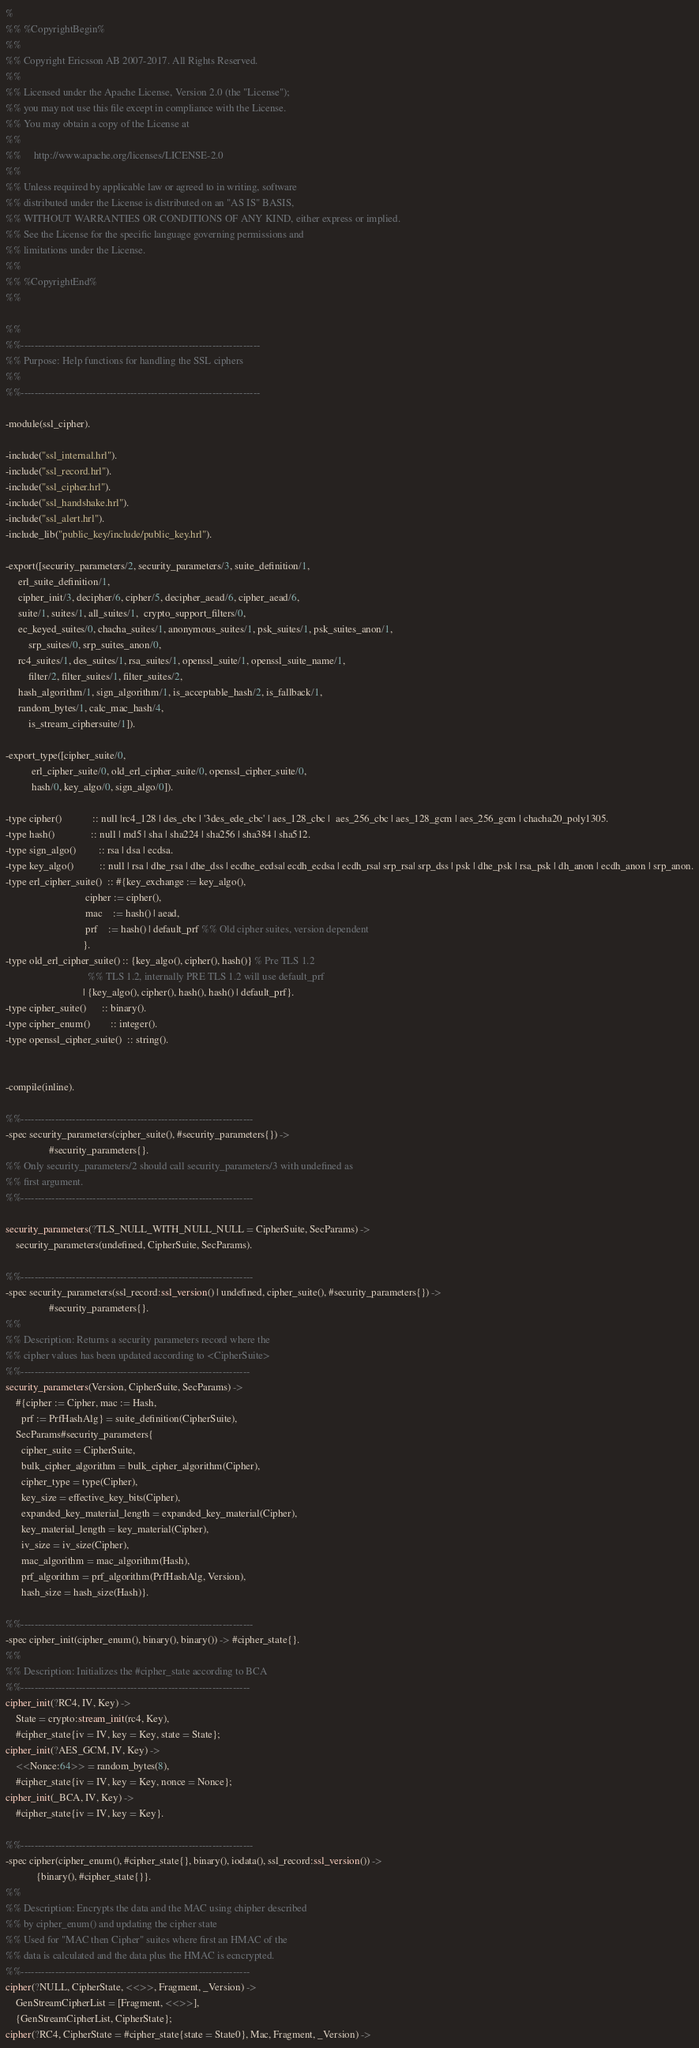<code> <loc_0><loc_0><loc_500><loc_500><_Erlang_>%
%% %CopyrightBegin%
%%
%% Copyright Ericsson AB 2007-2017. All Rights Reserved.
%%
%% Licensed under the Apache License, Version 2.0 (the "License");
%% you may not use this file except in compliance with the License.
%% You may obtain a copy of the License at
%%
%%     http://www.apache.org/licenses/LICENSE-2.0
%%
%% Unless required by applicable law or agreed to in writing, software
%% distributed under the License is distributed on an "AS IS" BASIS,
%% WITHOUT WARRANTIES OR CONDITIONS OF ANY KIND, either express or implied.
%% See the License for the specific language governing permissions and
%% limitations under the License.
%%
%% %CopyrightEnd%
%%

%%
%%----------------------------------------------------------------------
%% Purpose: Help functions for handling the SSL ciphers
%% 
%%----------------------------------------------------------------------

-module(ssl_cipher).

-include("ssl_internal.hrl").
-include("ssl_record.hrl").
-include("ssl_cipher.hrl").
-include("ssl_handshake.hrl").
-include("ssl_alert.hrl").
-include_lib("public_key/include/public_key.hrl").

-export([security_parameters/2, security_parameters/3, suite_definition/1,
	 erl_suite_definition/1,
	 cipher_init/3, decipher/6, cipher/5, decipher_aead/6, cipher_aead/6,
	 suite/1, suites/1, all_suites/1,  crypto_support_filters/0,
	 ec_keyed_suites/0, chacha_suites/1, anonymous_suites/1, psk_suites/1, psk_suites_anon/1, 
         srp_suites/0, srp_suites_anon/0,
	 rc4_suites/1, des_suites/1, rsa_suites/1, openssl_suite/1, openssl_suite_name/1, 
         filter/2, filter_suites/1, filter_suites/2,
	 hash_algorithm/1, sign_algorithm/1, is_acceptable_hash/2, is_fallback/1,
	 random_bytes/1, calc_mac_hash/4,
         is_stream_ciphersuite/1]).

-export_type([cipher_suite/0,
	      erl_cipher_suite/0, old_erl_cipher_suite/0, openssl_cipher_suite/0,
	      hash/0, key_algo/0, sign_algo/0]).

-type cipher()            :: null |rc4_128 | des_cbc | '3des_ede_cbc' | aes_128_cbc |  aes_256_cbc | aes_128_gcm | aes_256_gcm | chacha20_poly1305.
-type hash()              :: null | md5 | sha | sha224 | sha256 | sha384 | sha512.
-type sign_algo()         :: rsa | dsa | ecdsa.
-type key_algo()          :: null | rsa | dhe_rsa | dhe_dss | ecdhe_ecdsa| ecdh_ecdsa | ecdh_rsa| srp_rsa| srp_dss | psk | dhe_psk | rsa_psk | dh_anon | ecdh_anon | srp_anon.
-type erl_cipher_suite()  :: #{key_exchange := key_algo(),
                               cipher := cipher(),
                               mac    := hash() | aead,
                               prf    := hash() | default_prf %% Old cipher suites, version dependent
                              }.  
-type old_erl_cipher_suite() :: {key_algo(), cipher(), hash()} % Pre TLS 1.2 
                                %% TLS 1.2, internally PRE TLS 1.2 will use default_prf
                              | {key_algo(), cipher(), hash(), hash() | default_prf}. 
-type cipher_suite()      :: binary().
-type cipher_enum()        :: integer().
-type openssl_cipher_suite()  :: string().


-compile(inline).

%%--------------------------------------------------------------------
-spec security_parameters(cipher_suite(), #security_parameters{}) ->
				 #security_parameters{}.
%% Only security_parameters/2 should call security_parameters/3 with undefined as
%% first argument.
%%--------------------------------------------------------------------

security_parameters(?TLS_NULL_WITH_NULL_NULL = CipherSuite, SecParams) ->
    security_parameters(undefined, CipherSuite, SecParams).

%%--------------------------------------------------------------------
-spec security_parameters(ssl_record:ssl_version() | undefined, cipher_suite(), #security_parameters{}) ->
				 #security_parameters{}.
%%
%% Description: Returns a security parameters record where the
%% cipher values has been updated according to <CipherSuite> 
%%-------------------------------------------------------------------
security_parameters(Version, CipherSuite, SecParams) ->
    #{cipher := Cipher, mac := Hash, 
      prf := PrfHashAlg} = suite_definition(CipherSuite),
    SecParams#security_parameters{
      cipher_suite = CipherSuite,
      bulk_cipher_algorithm = bulk_cipher_algorithm(Cipher),
      cipher_type = type(Cipher),
      key_size = effective_key_bits(Cipher),
      expanded_key_material_length = expanded_key_material(Cipher),
      key_material_length = key_material(Cipher),
      iv_size = iv_size(Cipher),
      mac_algorithm = mac_algorithm(Hash),
      prf_algorithm = prf_algorithm(PrfHashAlg, Version),
      hash_size = hash_size(Hash)}.

%%--------------------------------------------------------------------
-spec cipher_init(cipher_enum(), binary(), binary()) -> #cipher_state{}.
%%
%% Description: Initializes the #cipher_state according to BCA
%%-------------------------------------------------------------------
cipher_init(?RC4, IV, Key) ->
    State = crypto:stream_init(rc4, Key),
    #cipher_state{iv = IV, key = Key, state = State};
cipher_init(?AES_GCM, IV, Key) ->
    <<Nonce:64>> = random_bytes(8),
    #cipher_state{iv = IV, key = Key, nonce = Nonce};
cipher_init(_BCA, IV, Key) ->
    #cipher_state{iv = IV, key = Key}.

%%--------------------------------------------------------------------
-spec cipher(cipher_enum(), #cipher_state{}, binary(), iodata(), ssl_record:ssl_version()) ->
		    {binary(), #cipher_state{}}. 
%%
%% Description: Encrypts the data and the MAC using chipher described
%% by cipher_enum() and updating the cipher state
%% Used for "MAC then Cipher" suites where first an HMAC of the
%% data is calculated and the data plus the HMAC is ecncrypted.
%%-------------------------------------------------------------------
cipher(?NULL, CipherState, <<>>, Fragment, _Version) ->
    GenStreamCipherList = [Fragment, <<>>],
    {GenStreamCipherList, CipherState};
cipher(?RC4, CipherState = #cipher_state{state = State0}, Mac, Fragment, _Version) -></code> 